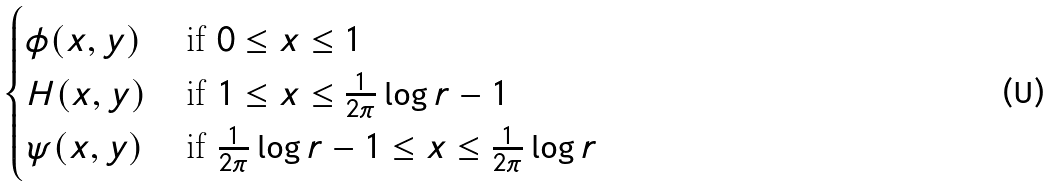Convert formula to latex. <formula><loc_0><loc_0><loc_500><loc_500>\begin{cases} \phi ( x , y ) & \, \text {if $0 \leq x \leq 1$} \\ H ( x , y ) & \, \text {if $ 1 \leq x \leq \frac{1}{2\pi}\log r-1$} \\ \psi ( x , y ) & \, \text {if $ \frac{1}{2\pi}\log r-1 \leq x \leq \frac{1}{2\pi}\log r$} \end{cases}</formula> 